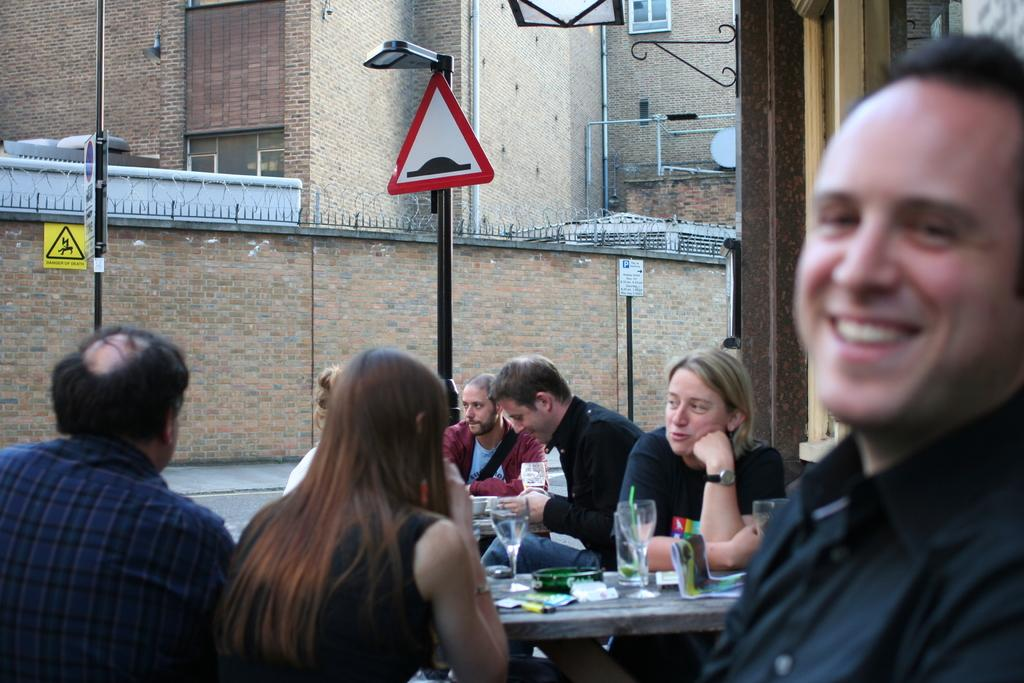What are the persons in the image doing? The persons in the image are sitting. What is in front of the persons? There is a table in front of the persons. What can be seen on the table? The table has glasses on it, and there are other objects on the table. What can be seen in the background of the image? There is a building in the background of the image. Where is the faucet located in the image? There is no faucet present in the image. What type of swing can be seen in the image? There is no swing present in the image. 